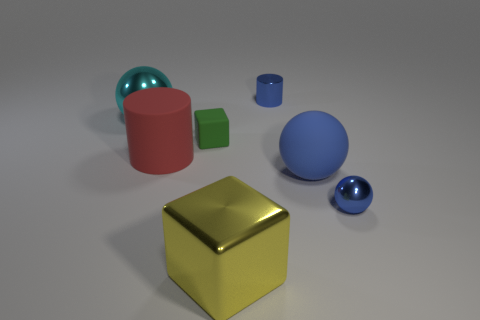What number of big things are yellow metal cubes or purple cubes?
Offer a very short reply. 1. Are there more tiny blue metallic balls than green rubber spheres?
Make the answer very short. Yes. There is a blue object that is the same material as the tiny green object; what is its size?
Offer a very short reply. Large. There is a metallic sphere that is right of the small rubber cube; is it the same size as the shiny ball to the left of the blue cylinder?
Your answer should be very brief. No. How many things are either matte things that are to the left of the large yellow metallic object or big matte things?
Give a very brief answer. 3. Are there fewer tiny green rubber objects than green shiny blocks?
Offer a very short reply. No. What shape is the tiny blue metallic thing in front of the big metal thing that is behind the metallic sphere on the right side of the matte block?
Provide a short and direct response. Sphere. The tiny metal object that is the same color as the tiny metal cylinder is what shape?
Ensure brevity in your answer.  Sphere. Are any tiny gray rubber cubes visible?
Offer a terse response. No. Do the red rubber cylinder and the blue metallic object that is in front of the large matte ball have the same size?
Keep it short and to the point. No. 